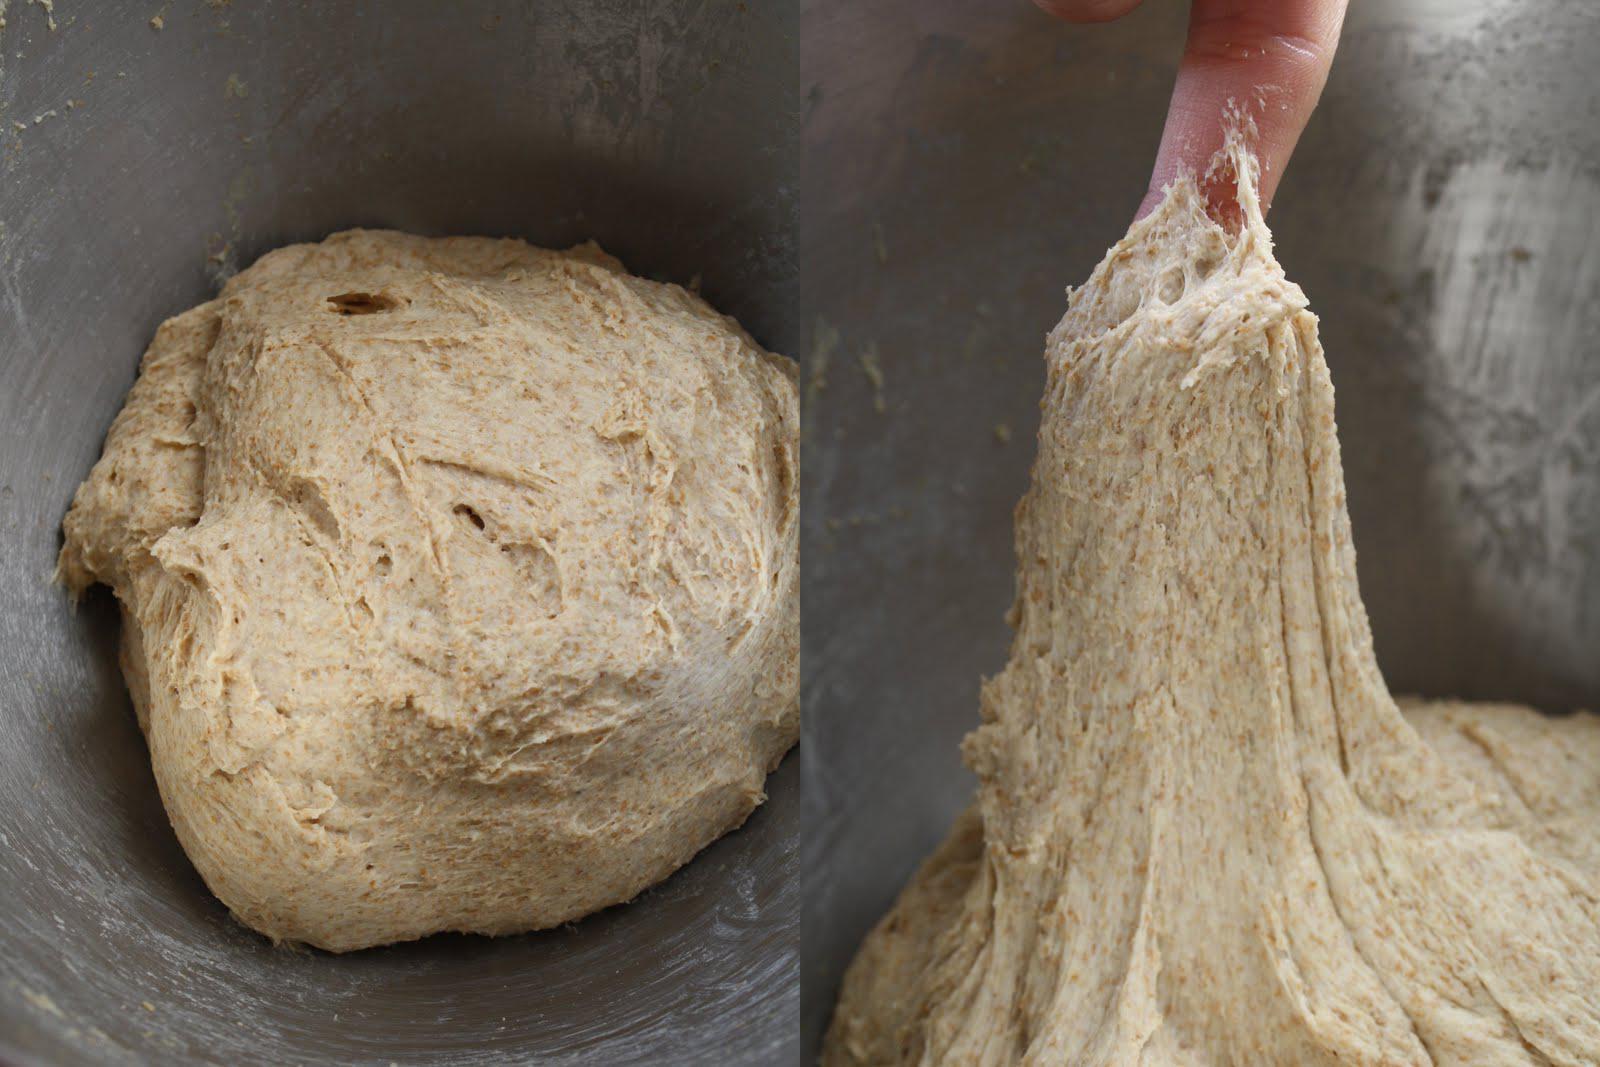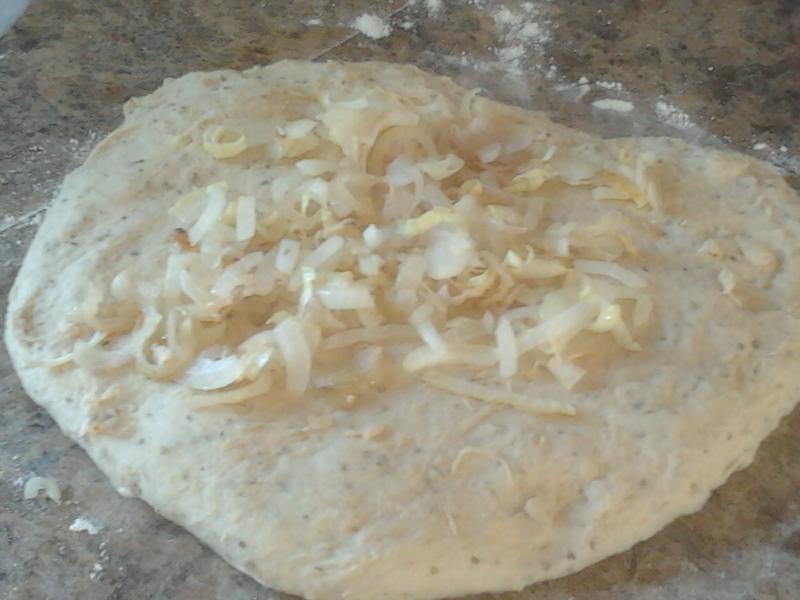The first image is the image on the left, the second image is the image on the right. Evaluate the accuracy of this statement regarding the images: "A person is lifting dough.". Is it true? Answer yes or no. Yes. The first image is the image on the left, the second image is the image on the right. Given the left and right images, does the statement "In at least one image a person's hand has wet dough stretching down." hold true? Answer yes or no. Yes. 